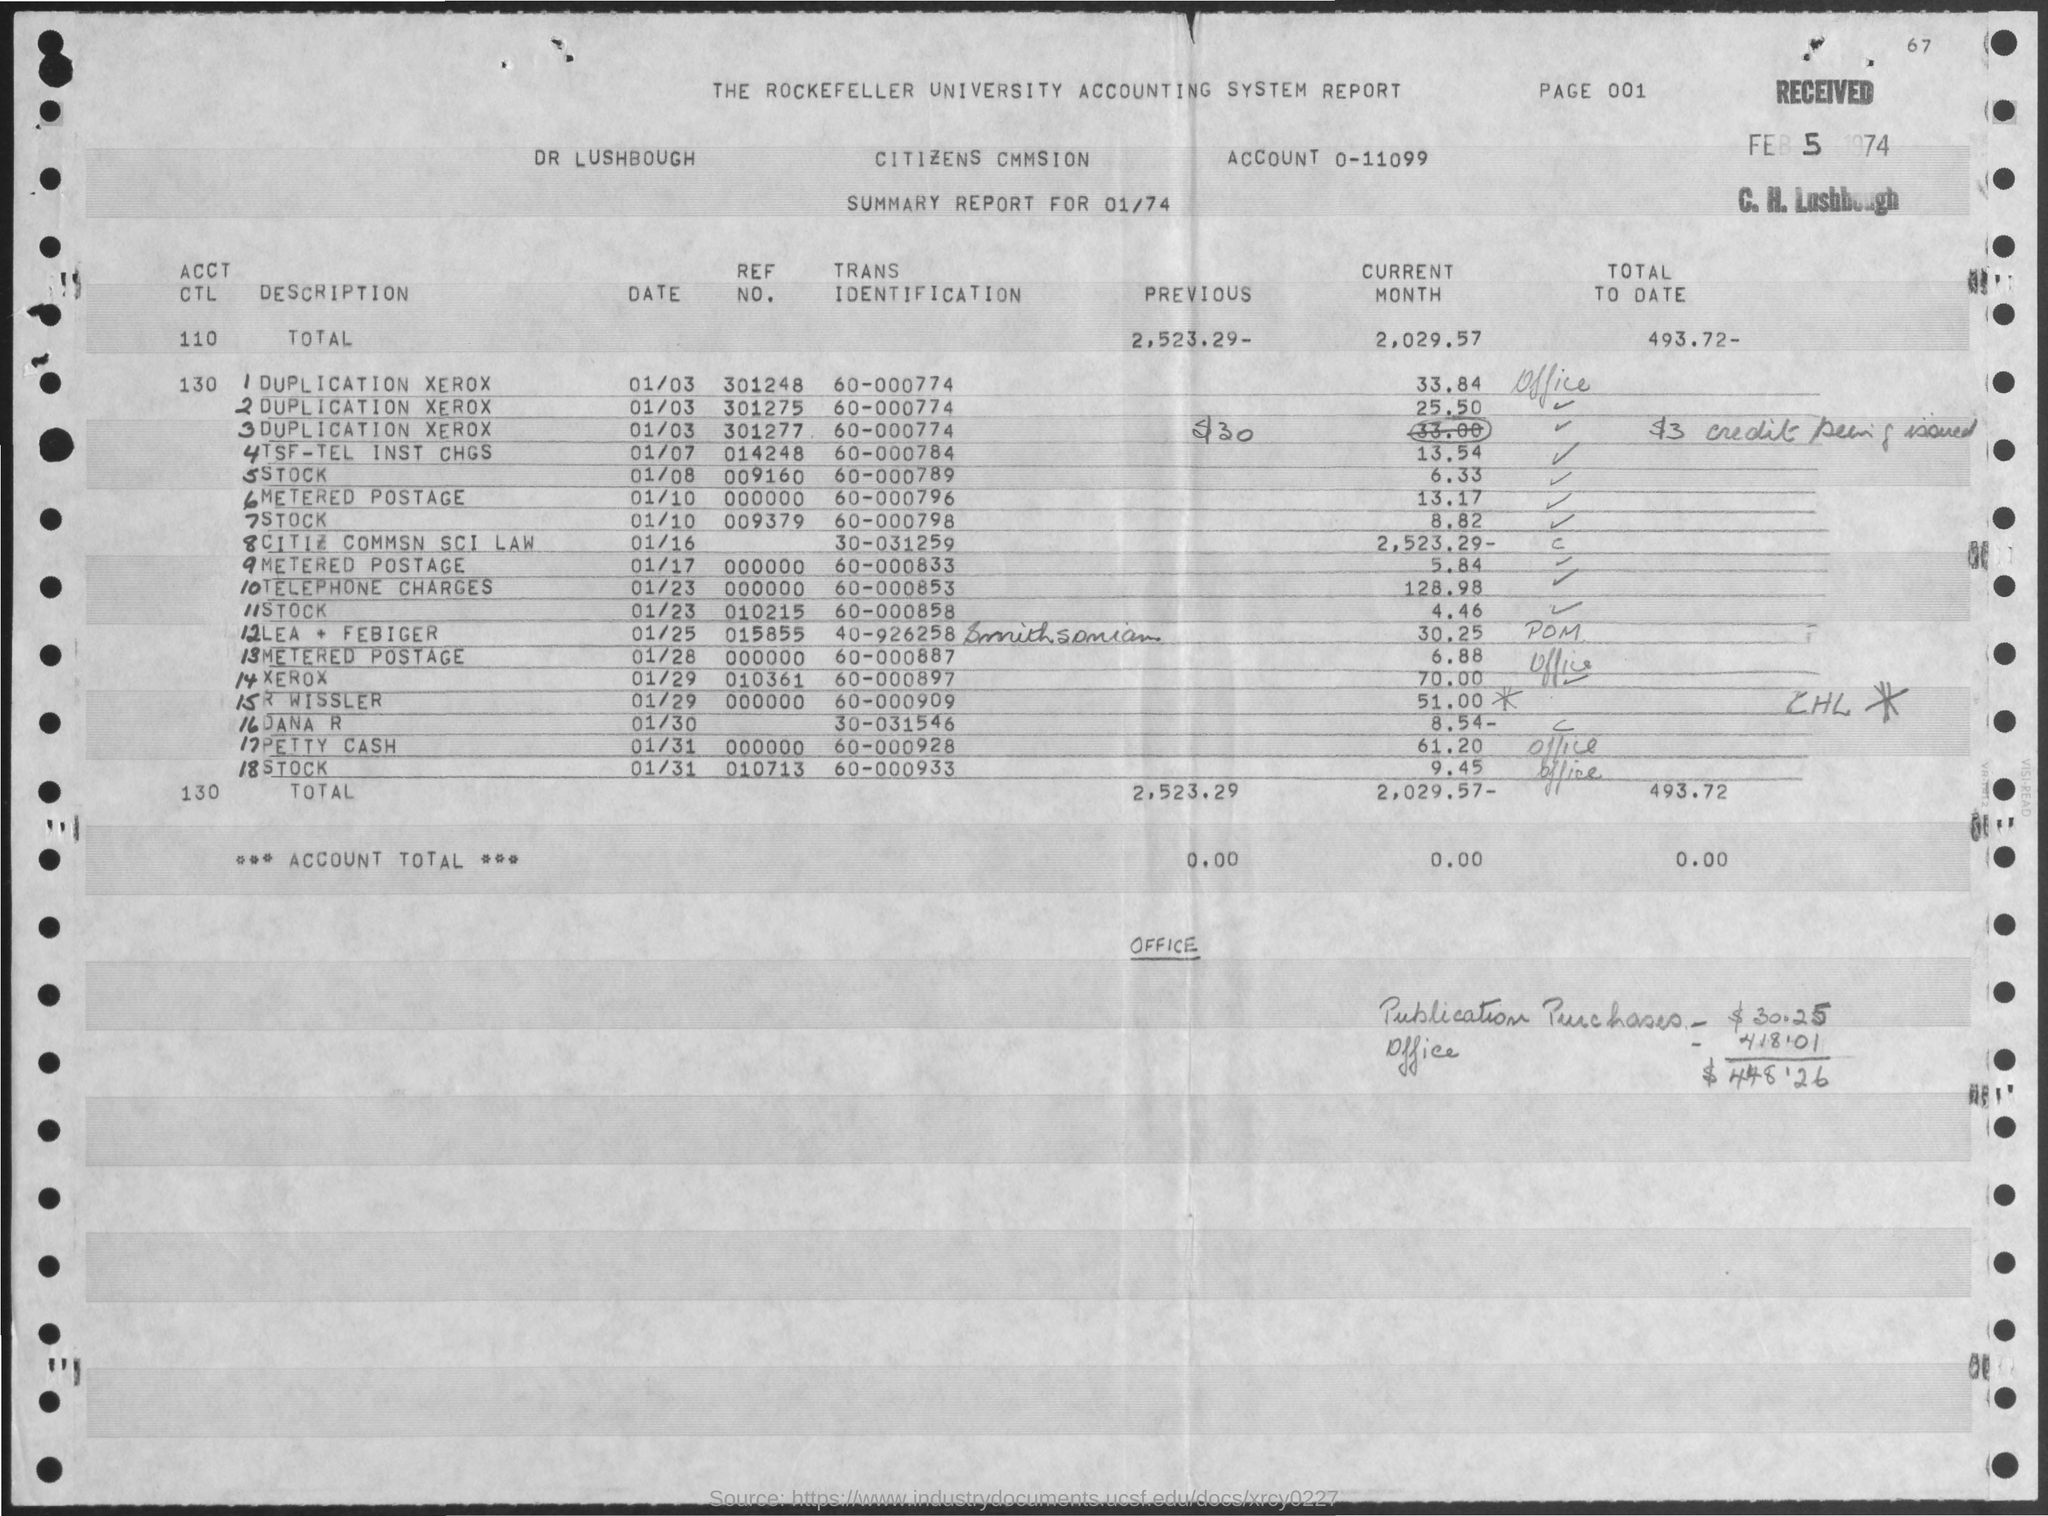Highlight a few significant elements in this photo. The trans identification number for telephone charges mentioned in the given report is 60-000853. The account number mentioned in the given report is 0-11099. The date mentioned in the summary report is 01/74. The previous amount mentioned in the given report is 2,523.29. The reference number for Xerox as mentioned in the given report is 010361... 